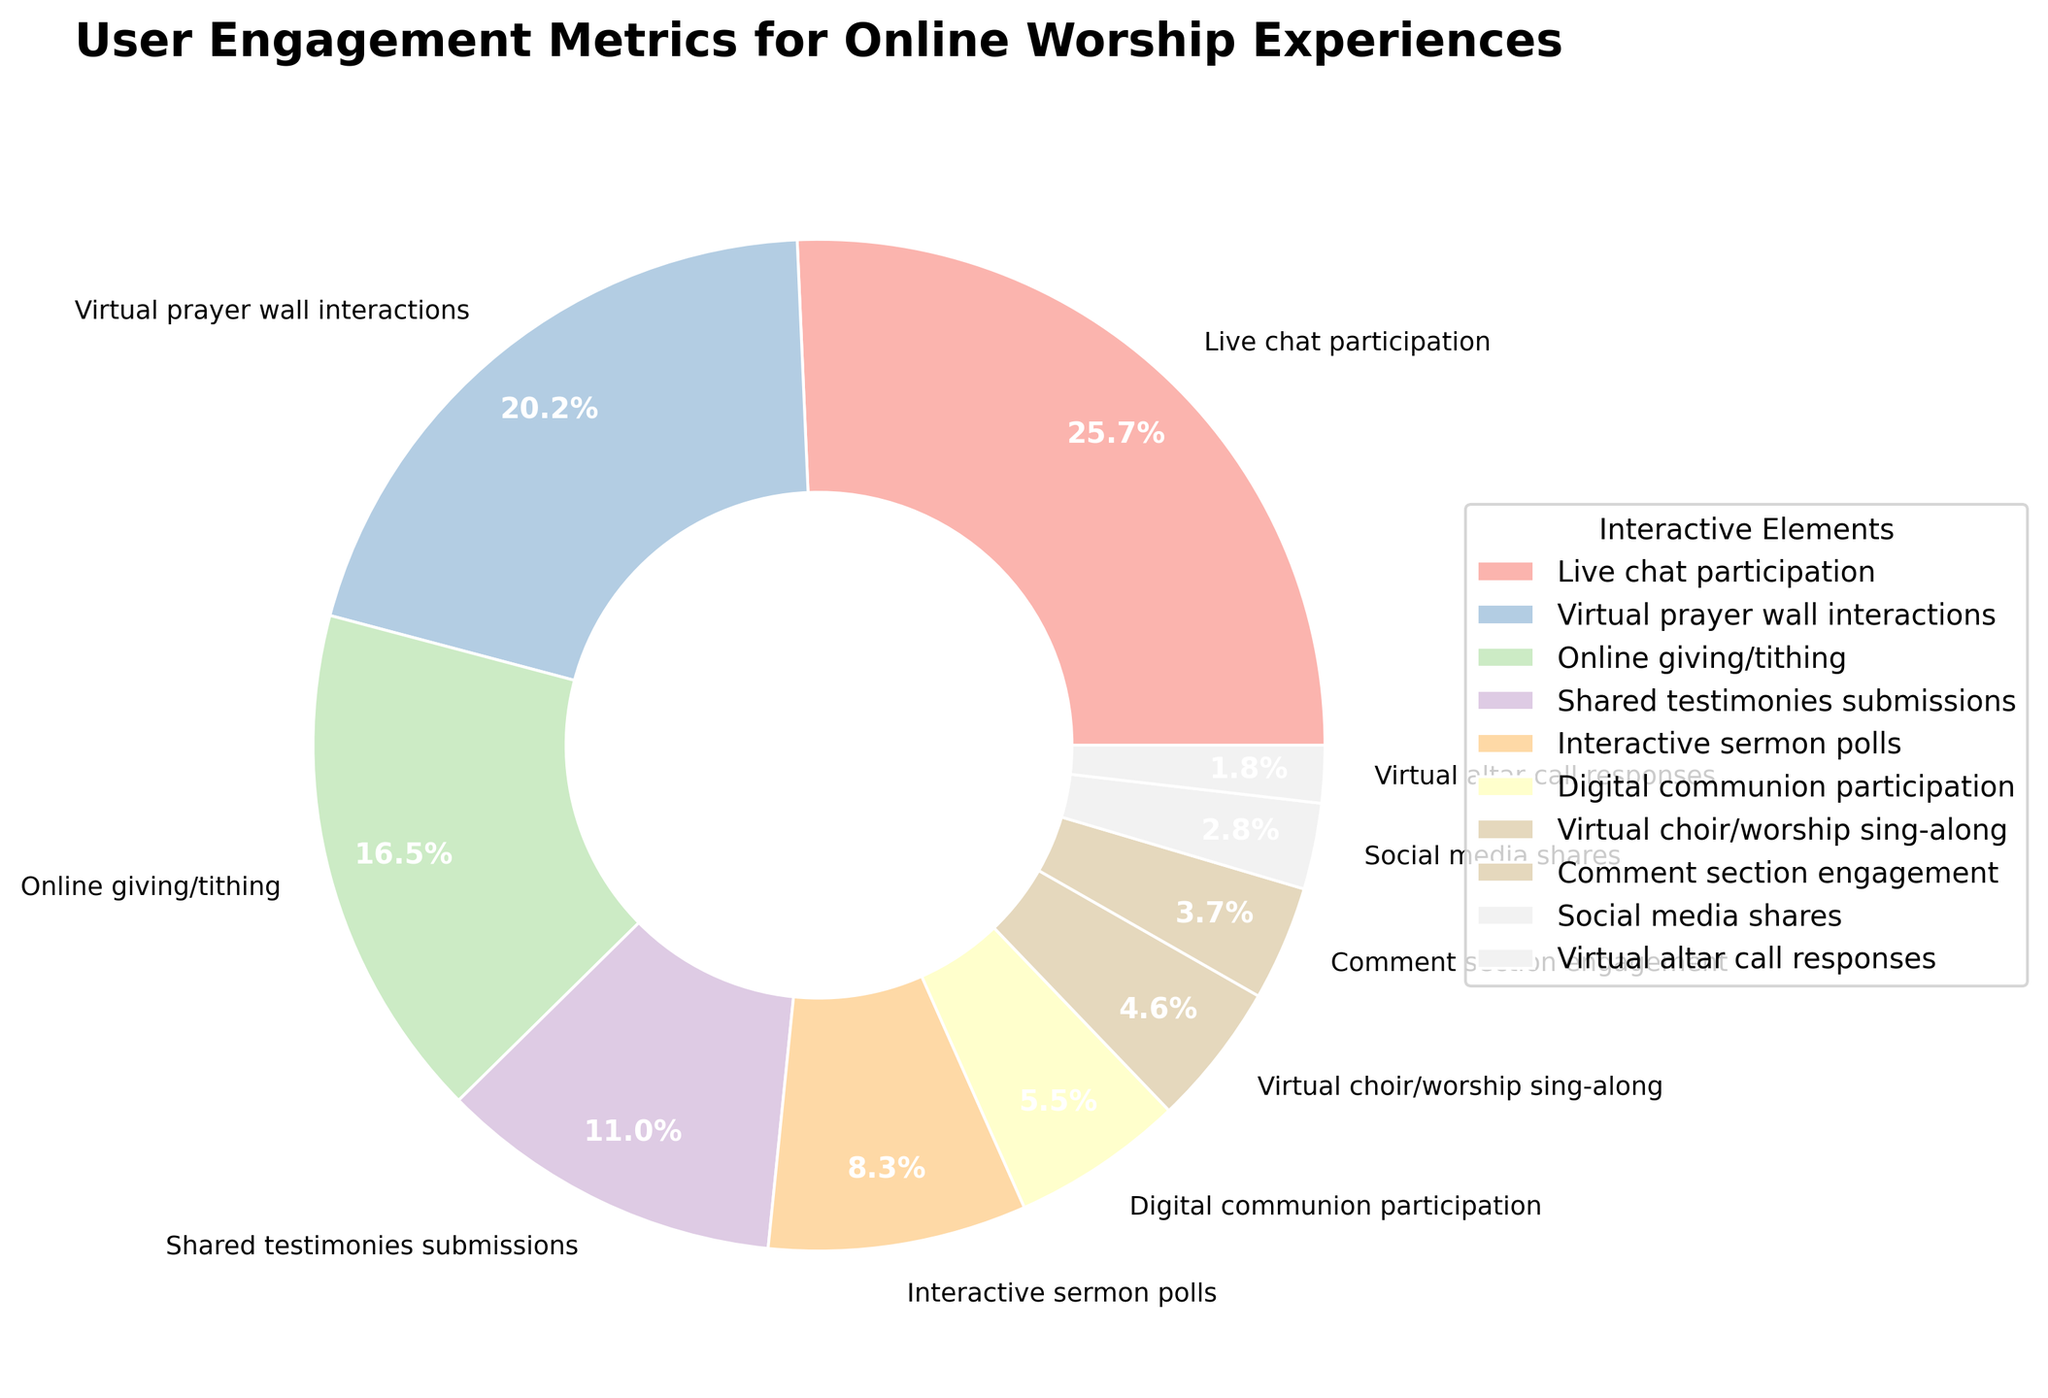What's the highest engagement percentage for any interactive element? First, look at each slice of the pie chart and identify the one with the largest percentage. The "Live chat participation" slice will be the largest, indicating its 28% engagement.
Answer: 28% Which interactive element has the lowest engagement percentage? Scan the pie chart for the smallest slice. The slice representing "Virtual altar call responses" is the smallest, indicating its 2% engagement.
Answer: 2% What is the difference in engagement between Live chat participation and Online giving/tithing? Find the engagement percentages for both elements: Live chat participation (28%) and Online giving/tithing (18%). Subtract the smaller percentage from the larger one: 28% - 18% = 10%.
Answer: 10% By how much does Virtual prayer wall interactions surpass Comment section engagement? Identify the engagement percentages for Virtual prayer wall interactions (22%) and Comment section engagement (4%). Subtract the smaller from the larger: 22% - 4% = 18%.
Answer: 18% Which element has a higher engagement, Interactive sermon polls or Digital communion participation? Compare the engagement percentages of both elements: Interactive sermon polls (9%) and Digital communion participation (6%). Since 9% is greater than 6%, Interactive sermon polls have higher engagement.
Answer: Interactive sermon polls How many interactive elements have an engagement percentage greater than 10%? Look at the pie chart and count the slices with percentages greater than 10%. They are Live chat participation (28%), Virtual prayer wall interactions (22%), and Online giving/tithing (18%), and Shared testimonies submissions (12%). There are 4 elements in total.
Answer: 4 Add the percentages of Social media shares and Virtual altar call responses. What is their combined engagement? Locate the slices for Social media shares (3%) and Virtual altar call responses (2%). Add them together: 3% + 2% = 5%.
Answer: 5% What is the total engagement percentage for Virtual choir/worship sing-along, Comment section engagement, and Social media shares combined? Find the engagement percentages for each: Virtual choir/worship sing-along (5%), Comment section engagement (4%), and Social media shares (3%). Sum them up: 5% + 4% + 3% = 12%.
Answer: 12% Is the engagement percentage for Digital communion participation less than half of Live chat participation? Compare Digital communion participation (6%) with half of Live chat participation (28% / 2 = 14%). Since 6% is less than 14%, the answer is yes.
Answer: Yes Calculate the average engagement percentage for the elements with less than 10% engagement each. Identify the percentages of elements with <10% engagement: Interactive sermon polls (9%), Digital communion participation (6%), Virtual choir/worship sing-along (5%), Comment section engagement (4%), Social media shares (3%), and Virtual altar call responses (2%). Sum these percentages: 9% + 6% + 5% + 4% + 3% + 2% = 29%. Divide by the number of elements, which is 6: 29% / 6 ≈ 4.83%.
Answer: 4.83% 